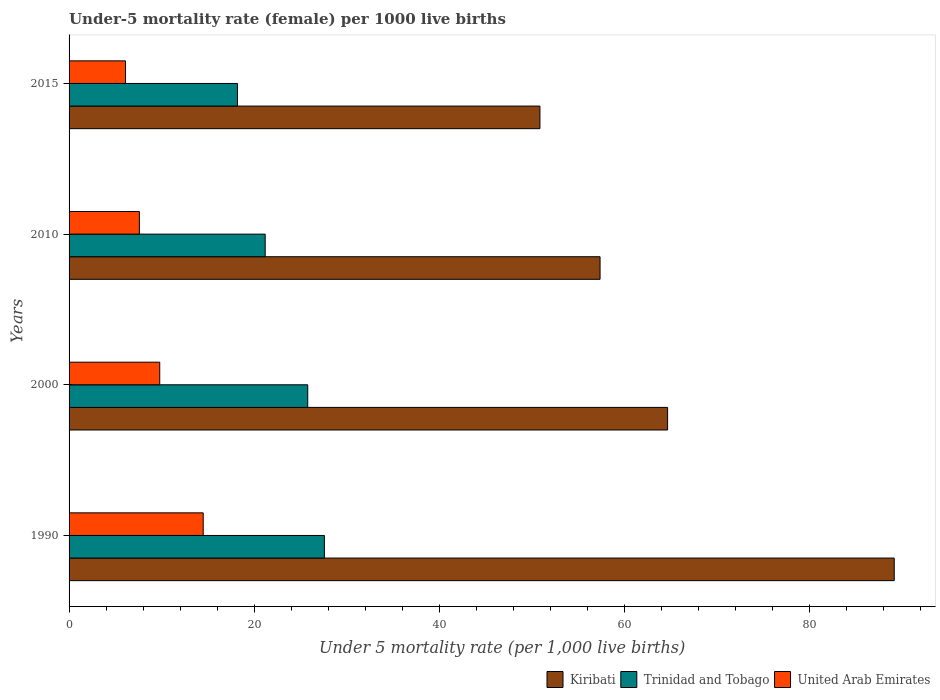How many different coloured bars are there?
Offer a very short reply. 3. How many groups of bars are there?
Keep it short and to the point. 4. Are the number of bars on each tick of the Y-axis equal?
Keep it short and to the point. Yes. How many bars are there on the 2nd tick from the bottom?
Ensure brevity in your answer.  3. What is the label of the 2nd group of bars from the top?
Your answer should be very brief. 2010. In how many cases, is the number of bars for a given year not equal to the number of legend labels?
Keep it short and to the point. 0. What is the under-five mortality rate in United Arab Emirates in 1990?
Your response must be concise. 14.5. Across all years, what is the maximum under-five mortality rate in Trinidad and Tobago?
Keep it short and to the point. 27.6. In which year was the under-five mortality rate in Kiribati minimum?
Provide a succinct answer. 2015. What is the total under-five mortality rate in Kiribati in the graph?
Keep it short and to the point. 262.2. What is the difference between the under-five mortality rate in Kiribati in 1990 and that in 2010?
Make the answer very short. 31.8. What is the difference between the under-five mortality rate in Trinidad and Tobago in 2000 and the under-five mortality rate in United Arab Emirates in 2015?
Offer a very short reply. 19.7. What is the average under-five mortality rate in Trinidad and Tobago per year?
Keep it short and to the point. 23.2. In the year 2000, what is the difference between the under-five mortality rate in Kiribati and under-five mortality rate in United Arab Emirates?
Ensure brevity in your answer.  54.9. What is the ratio of the under-five mortality rate in Kiribati in 1990 to that in 2010?
Offer a very short reply. 1.55. Is the sum of the under-five mortality rate in Kiribati in 2000 and 2010 greater than the maximum under-five mortality rate in United Arab Emirates across all years?
Make the answer very short. Yes. What does the 1st bar from the top in 1990 represents?
Your answer should be compact. United Arab Emirates. What does the 1st bar from the bottom in 2000 represents?
Your answer should be very brief. Kiribati. Is it the case that in every year, the sum of the under-five mortality rate in Trinidad and Tobago and under-five mortality rate in United Arab Emirates is greater than the under-five mortality rate in Kiribati?
Your answer should be compact. No. What is the difference between two consecutive major ticks on the X-axis?
Offer a terse response. 20. How are the legend labels stacked?
Offer a terse response. Horizontal. What is the title of the graph?
Ensure brevity in your answer.  Under-5 mortality rate (female) per 1000 live births. What is the label or title of the X-axis?
Offer a terse response. Under 5 mortality rate (per 1,0 live births). What is the Under 5 mortality rate (per 1,000 live births) in Kiribati in 1990?
Your answer should be compact. 89.2. What is the Under 5 mortality rate (per 1,000 live births) of Trinidad and Tobago in 1990?
Your answer should be very brief. 27.6. What is the Under 5 mortality rate (per 1,000 live births) of Kiribati in 2000?
Your answer should be compact. 64.7. What is the Under 5 mortality rate (per 1,000 live births) in Trinidad and Tobago in 2000?
Your answer should be very brief. 25.8. What is the Under 5 mortality rate (per 1,000 live births) in Kiribati in 2010?
Keep it short and to the point. 57.4. What is the Under 5 mortality rate (per 1,000 live births) in Trinidad and Tobago in 2010?
Provide a short and direct response. 21.2. What is the Under 5 mortality rate (per 1,000 live births) of United Arab Emirates in 2010?
Ensure brevity in your answer.  7.6. What is the Under 5 mortality rate (per 1,000 live births) of Kiribati in 2015?
Make the answer very short. 50.9. Across all years, what is the maximum Under 5 mortality rate (per 1,000 live births) of Kiribati?
Give a very brief answer. 89.2. Across all years, what is the maximum Under 5 mortality rate (per 1,000 live births) in Trinidad and Tobago?
Your answer should be compact. 27.6. Across all years, what is the maximum Under 5 mortality rate (per 1,000 live births) in United Arab Emirates?
Keep it short and to the point. 14.5. Across all years, what is the minimum Under 5 mortality rate (per 1,000 live births) of Kiribati?
Your answer should be very brief. 50.9. Across all years, what is the minimum Under 5 mortality rate (per 1,000 live births) of Trinidad and Tobago?
Ensure brevity in your answer.  18.2. Across all years, what is the minimum Under 5 mortality rate (per 1,000 live births) of United Arab Emirates?
Ensure brevity in your answer.  6.1. What is the total Under 5 mortality rate (per 1,000 live births) of Kiribati in the graph?
Offer a terse response. 262.2. What is the total Under 5 mortality rate (per 1,000 live births) of Trinidad and Tobago in the graph?
Give a very brief answer. 92.8. What is the total Under 5 mortality rate (per 1,000 live births) of United Arab Emirates in the graph?
Your response must be concise. 38. What is the difference between the Under 5 mortality rate (per 1,000 live births) of Kiribati in 1990 and that in 2010?
Give a very brief answer. 31.8. What is the difference between the Under 5 mortality rate (per 1,000 live births) in Kiribati in 1990 and that in 2015?
Your answer should be compact. 38.3. What is the difference between the Under 5 mortality rate (per 1,000 live births) of Trinidad and Tobago in 1990 and that in 2015?
Give a very brief answer. 9.4. What is the difference between the Under 5 mortality rate (per 1,000 live births) in United Arab Emirates in 2000 and that in 2010?
Your response must be concise. 2.2. What is the difference between the Under 5 mortality rate (per 1,000 live births) of Kiribati in 2000 and that in 2015?
Give a very brief answer. 13.8. What is the difference between the Under 5 mortality rate (per 1,000 live births) of Trinidad and Tobago in 2000 and that in 2015?
Provide a short and direct response. 7.6. What is the difference between the Under 5 mortality rate (per 1,000 live births) in United Arab Emirates in 2000 and that in 2015?
Provide a short and direct response. 3.7. What is the difference between the Under 5 mortality rate (per 1,000 live births) of Trinidad and Tobago in 2010 and that in 2015?
Ensure brevity in your answer.  3. What is the difference between the Under 5 mortality rate (per 1,000 live births) in Kiribati in 1990 and the Under 5 mortality rate (per 1,000 live births) in Trinidad and Tobago in 2000?
Make the answer very short. 63.4. What is the difference between the Under 5 mortality rate (per 1,000 live births) of Kiribati in 1990 and the Under 5 mortality rate (per 1,000 live births) of United Arab Emirates in 2000?
Provide a succinct answer. 79.4. What is the difference between the Under 5 mortality rate (per 1,000 live births) of Kiribati in 1990 and the Under 5 mortality rate (per 1,000 live births) of United Arab Emirates in 2010?
Your answer should be very brief. 81.6. What is the difference between the Under 5 mortality rate (per 1,000 live births) in Kiribati in 1990 and the Under 5 mortality rate (per 1,000 live births) in Trinidad and Tobago in 2015?
Ensure brevity in your answer.  71. What is the difference between the Under 5 mortality rate (per 1,000 live births) in Kiribati in 1990 and the Under 5 mortality rate (per 1,000 live births) in United Arab Emirates in 2015?
Your answer should be compact. 83.1. What is the difference between the Under 5 mortality rate (per 1,000 live births) in Trinidad and Tobago in 1990 and the Under 5 mortality rate (per 1,000 live births) in United Arab Emirates in 2015?
Make the answer very short. 21.5. What is the difference between the Under 5 mortality rate (per 1,000 live births) in Kiribati in 2000 and the Under 5 mortality rate (per 1,000 live births) in Trinidad and Tobago in 2010?
Offer a terse response. 43.5. What is the difference between the Under 5 mortality rate (per 1,000 live births) in Kiribati in 2000 and the Under 5 mortality rate (per 1,000 live births) in United Arab Emirates in 2010?
Make the answer very short. 57.1. What is the difference between the Under 5 mortality rate (per 1,000 live births) of Kiribati in 2000 and the Under 5 mortality rate (per 1,000 live births) of Trinidad and Tobago in 2015?
Ensure brevity in your answer.  46.5. What is the difference between the Under 5 mortality rate (per 1,000 live births) of Kiribati in 2000 and the Under 5 mortality rate (per 1,000 live births) of United Arab Emirates in 2015?
Keep it short and to the point. 58.6. What is the difference between the Under 5 mortality rate (per 1,000 live births) of Kiribati in 2010 and the Under 5 mortality rate (per 1,000 live births) of Trinidad and Tobago in 2015?
Ensure brevity in your answer.  39.2. What is the difference between the Under 5 mortality rate (per 1,000 live births) of Kiribati in 2010 and the Under 5 mortality rate (per 1,000 live births) of United Arab Emirates in 2015?
Make the answer very short. 51.3. What is the difference between the Under 5 mortality rate (per 1,000 live births) in Trinidad and Tobago in 2010 and the Under 5 mortality rate (per 1,000 live births) in United Arab Emirates in 2015?
Give a very brief answer. 15.1. What is the average Under 5 mortality rate (per 1,000 live births) of Kiribati per year?
Provide a succinct answer. 65.55. What is the average Under 5 mortality rate (per 1,000 live births) of Trinidad and Tobago per year?
Your answer should be compact. 23.2. What is the average Under 5 mortality rate (per 1,000 live births) in United Arab Emirates per year?
Your answer should be very brief. 9.5. In the year 1990, what is the difference between the Under 5 mortality rate (per 1,000 live births) of Kiribati and Under 5 mortality rate (per 1,000 live births) of Trinidad and Tobago?
Your answer should be very brief. 61.6. In the year 1990, what is the difference between the Under 5 mortality rate (per 1,000 live births) of Kiribati and Under 5 mortality rate (per 1,000 live births) of United Arab Emirates?
Make the answer very short. 74.7. In the year 1990, what is the difference between the Under 5 mortality rate (per 1,000 live births) in Trinidad and Tobago and Under 5 mortality rate (per 1,000 live births) in United Arab Emirates?
Ensure brevity in your answer.  13.1. In the year 2000, what is the difference between the Under 5 mortality rate (per 1,000 live births) in Kiribati and Under 5 mortality rate (per 1,000 live births) in Trinidad and Tobago?
Give a very brief answer. 38.9. In the year 2000, what is the difference between the Under 5 mortality rate (per 1,000 live births) in Kiribati and Under 5 mortality rate (per 1,000 live births) in United Arab Emirates?
Your answer should be very brief. 54.9. In the year 2000, what is the difference between the Under 5 mortality rate (per 1,000 live births) in Trinidad and Tobago and Under 5 mortality rate (per 1,000 live births) in United Arab Emirates?
Provide a short and direct response. 16. In the year 2010, what is the difference between the Under 5 mortality rate (per 1,000 live births) of Kiribati and Under 5 mortality rate (per 1,000 live births) of Trinidad and Tobago?
Offer a terse response. 36.2. In the year 2010, what is the difference between the Under 5 mortality rate (per 1,000 live births) in Kiribati and Under 5 mortality rate (per 1,000 live births) in United Arab Emirates?
Your answer should be compact. 49.8. In the year 2015, what is the difference between the Under 5 mortality rate (per 1,000 live births) in Kiribati and Under 5 mortality rate (per 1,000 live births) in Trinidad and Tobago?
Your answer should be very brief. 32.7. In the year 2015, what is the difference between the Under 5 mortality rate (per 1,000 live births) in Kiribati and Under 5 mortality rate (per 1,000 live births) in United Arab Emirates?
Your response must be concise. 44.8. In the year 2015, what is the difference between the Under 5 mortality rate (per 1,000 live births) in Trinidad and Tobago and Under 5 mortality rate (per 1,000 live births) in United Arab Emirates?
Offer a terse response. 12.1. What is the ratio of the Under 5 mortality rate (per 1,000 live births) of Kiribati in 1990 to that in 2000?
Keep it short and to the point. 1.38. What is the ratio of the Under 5 mortality rate (per 1,000 live births) in Trinidad and Tobago in 1990 to that in 2000?
Offer a terse response. 1.07. What is the ratio of the Under 5 mortality rate (per 1,000 live births) in United Arab Emirates in 1990 to that in 2000?
Give a very brief answer. 1.48. What is the ratio of the Under 5 mortality rate (per 1,000 live births) of Kiribati in 1990 to that in 2010?
Provide a succinct answer. 1.55. What is the ratio of the Under 5 mortality rate (per 1,000 live births) of Trinidad and Tobago in 1990 to that in 2010?
Provide a short and direct response. 1.3. What is the ratio of the Under 5 mortality rate (per 1,000 live births) in United Arab Emirates in 1990 to that in 2010?
Ensure brevity in your answer.  1.91. What is the ratio of the Under 5 mortality rate (per 1,000 live births) of Kiribati in 1990 to that in 2015?
Ensure brevity in your answer.  1.75. What is the ratio of the Under 5 mortality rate (per 1,000 live births) in Trinidad and Tobago in 1990 to that in 2015?
Offer a terse response. 1.52. What is the ratio of the Under 5 mortality rate (per 1,000 live births) in United Arab Emirates in 1990 to that in 2015?
Your answer should be very brief. 2.38. What is the ratio of the Under 5 mortality rate (per 1,000 live births) in Kiribati in 2000 to that in 2010?
Your answer should be very brief. 1.13. What is the ratio of the Under 5 mortality rate (per 1,000 live births) of Trinidad and Tobago in 2000 to that in 2010?
Your answer should be compact. 1.22. What is the ratio of the Under 5 mortality rate (per 1,000 live births) in United Arab Emirates in 2000 to that in 2010?
Make the answer very short. 1.29. What is the ratio of the Under 5 mortality rate (per 1,000 live births) in Kiribati in 2000 to that in 2015?
Offer a very short reply. 1.27. What is the ratio of the Under 5 mortality rate (per 1,000 live births) in Trinidad and Tobago in 2000 to that in 2015?
Your answer should be compact. 1.42. What is the ratio of the Under 5 mortality rate (per 1,000 live births) in United Arab Emirates in 2000 to that in 2015?
Keep it short and to the point. 1.61. What is the ratio of the Under 5 mortality rate (per 1,000 live births) in Kiribati in 2010 to that in 2015?
Your response must be concise. 1.13. What is the ratio of the Under 5 mortality rate (per 1,000 live births) of Trinidad and Tobago in 2010 to that in 2015?
Make the answer very short. 1.16. What is the ratio of the Under 5 mortality rate (per 1,000 live births) of United Arab Emirates in 2010 to that in 2015?
Offer a terse response. 1.25. What is the difference between the highest and the second highest Under 5 mortality rate (per 1,000 live births) of Trinidad and Tobago?
Your answer should be very brief. 1.8. What is the difference between the highest and the lowest Under 5 mortality rate (per 1,000 live births) in Kiribati?
Ensure brevity in your answer.  38.3. 